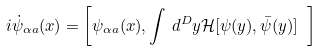<formula> <loc_0><loc_0><loc_500><loc_500>i \dot { \psi } _ { \alpha a } ( x ) = \left [ \psi _ { \alpha a } ( x ) , \int \, d ^ { D } y \mathcal { H } [ \psi ( y ) , \bar { \psi } ( y ) ] \ \right ]</formula> 